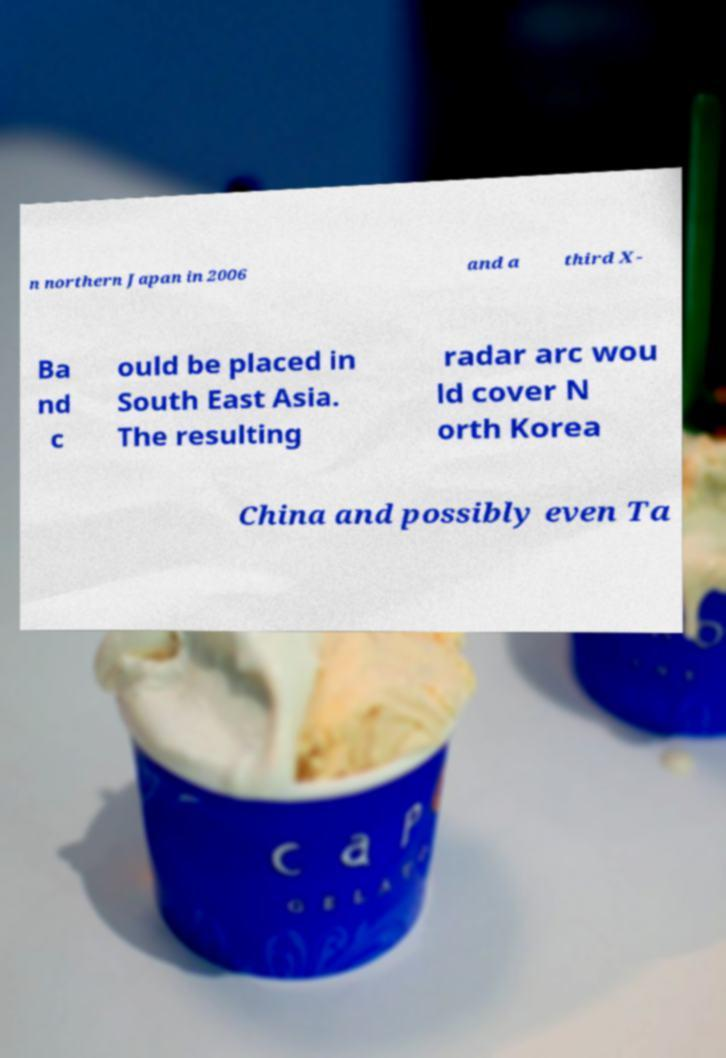What messages or text are displayed in this image? I need them in a readable, typed format. n northern Japan in 2006 and a third X- Ba nd c ould be placed in South East Asia. The resulting radar arc wou ld cover N orth Korea China and possibly even Ta 